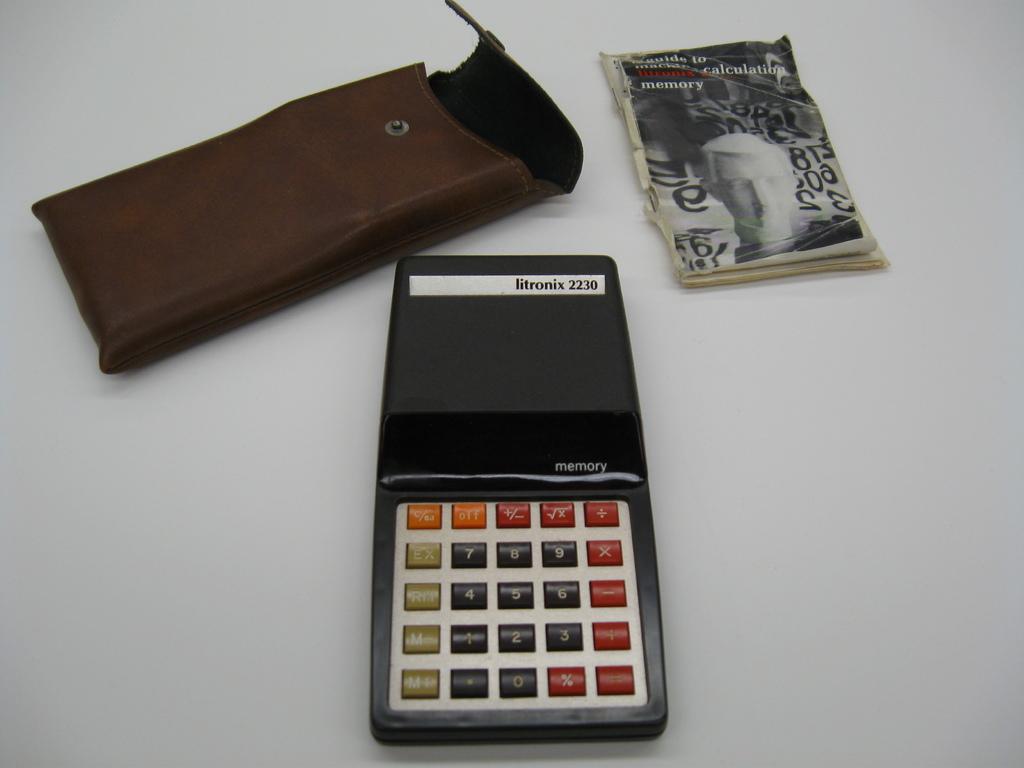What type of calculator is this?
Your answer should be compact. Litronix 2230. What's the model name of this calculator?
Offer a very short reply. Litronix 2230. 